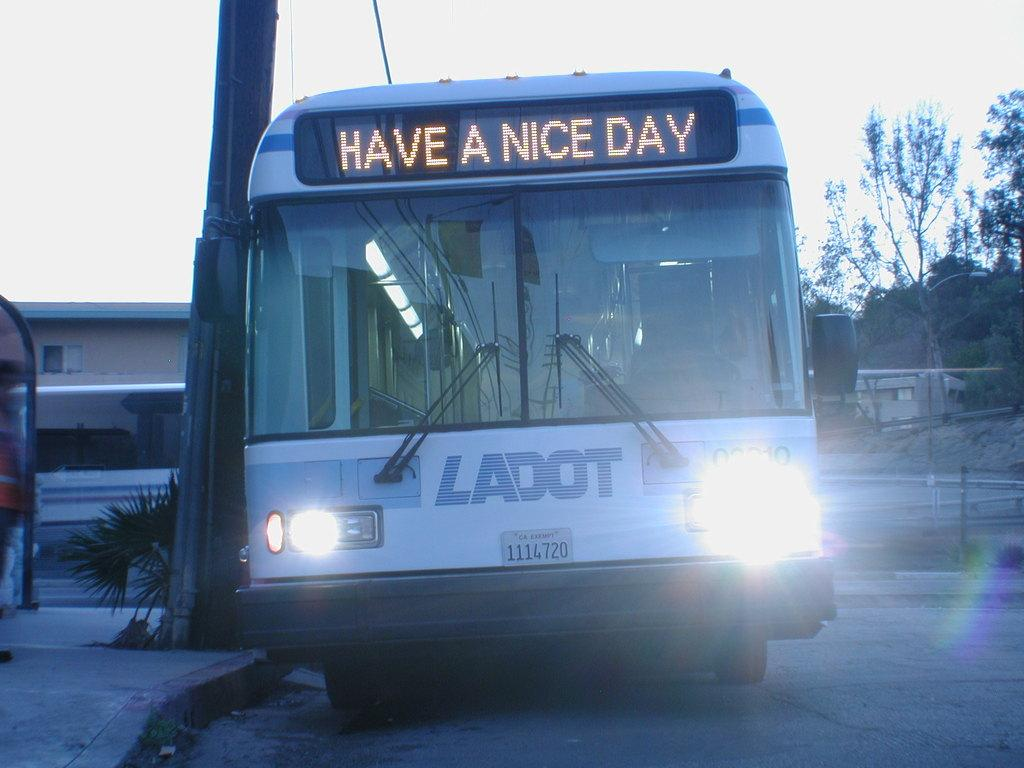Provide a one-sentence caption for the provided image. a bus that says 'have a nice day' in the front digital portion. 